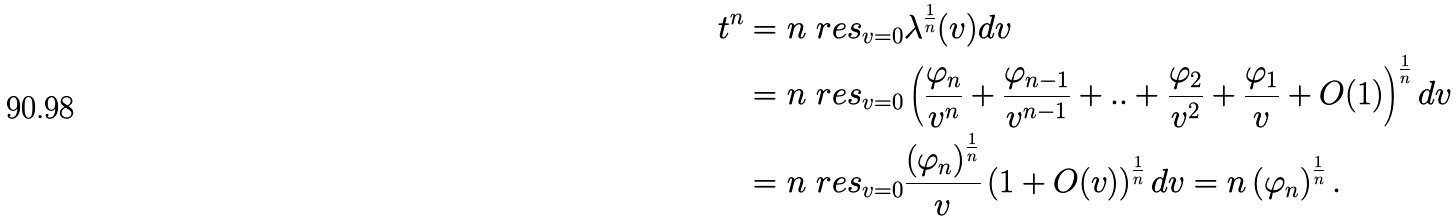<formula> <loc_0><loc_0><loc_500><loc_500>t ^ { n } & = n \ r e s _ { v = 0 } \lambda ^ { \frac { 1 } { n } } ( v ) d v \\ & = n \ r e s _ { v = 0 } \left ( \frac { \varphi _ { n } } { v ^ { n } } + \frac { \varphi _ { n - 1 } } { v ^ { n - 1 } } + . . + \frac { \varphi _ { 2 } } { v ^ { 2 } } + \frac { \varphi _ { 1 } } { v } + O ( 1 ) \right ) ^ { \frac { 1 } { n } } d v \\ & = n \ r e s _ { v = 0 } \frac { \left ( \varphi _ { n } \right ) ^ { \frac { 1 } { n } } } { v } \left ( 1 + O ( v ) \right ) ^ { \frac { 1 } { n } } d v = n \left ( \varphi _ { n } \right ) ^ { \frac { 1 } { n } } .</formula> 